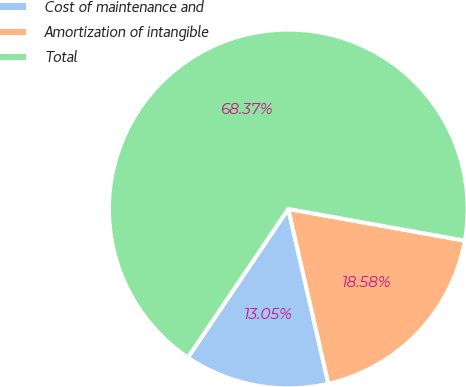Convert chart to OTSL. <chart><loc_0><loc_0><loc_500><loc_500><pie_chart><fcel>Cost of maintenance and<fcel>Amortization of intangible<fcel>Total<nl><fcel>13.05%<fcel>18.58%<fcel>68.37%<nl></chart> 